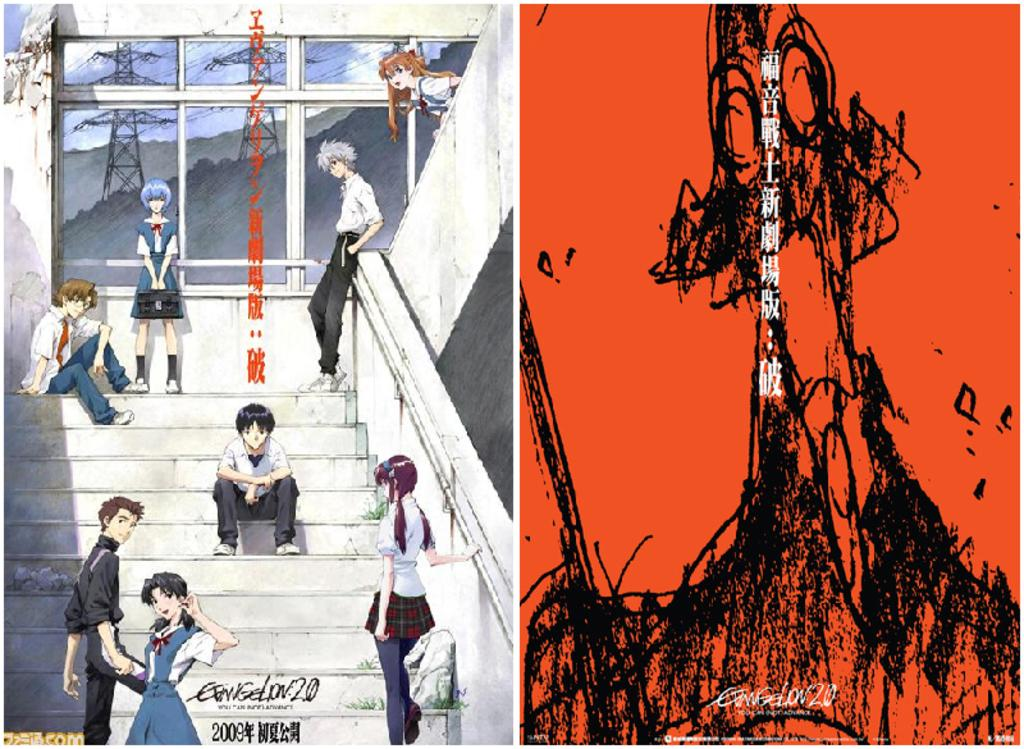What are the people in the image doing? There are people standing and sitting in the image. Can you describe the positions of the people in the image? Some people are standing, while others are sitting. What type of faucet can be seen in the image? There is no faucet present in the image. How is the string being used by the people in the image? There is no string present in the image. 